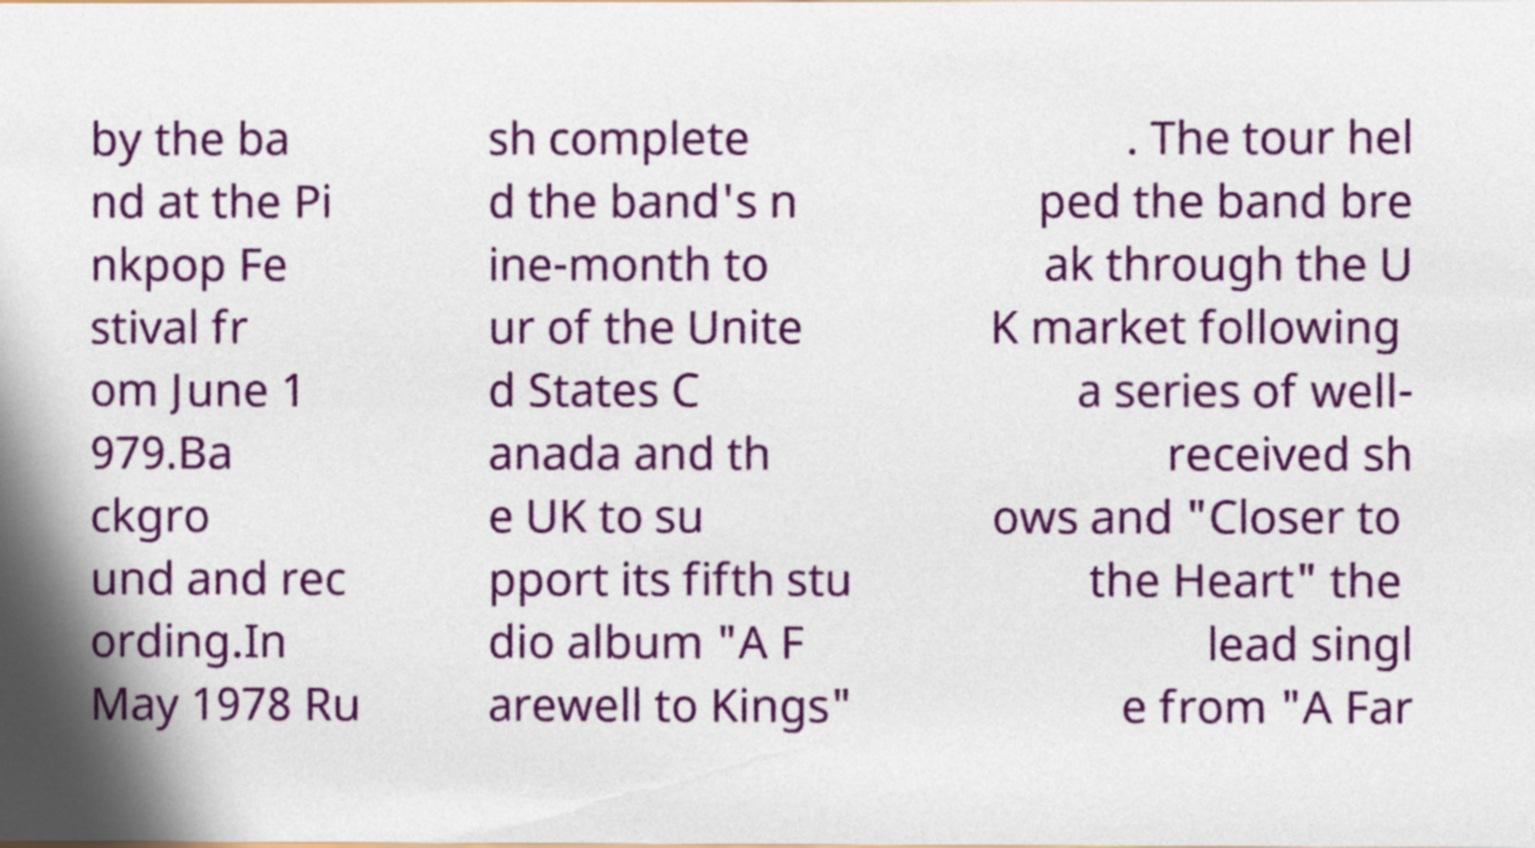Can you read and provide the text displayed in the image?This photo seems to have some interesting text. Can you extract and type it out for me? by the ba nd at the Pi nkpop Fe stival fr om June 1 979.Ba ckgro und and rec ording.In May 1978 Ru sh complete d the band's n ine-month to ur of the Unite d States C anada and th e UK to su pport its fifth stu dio album "A F arewell to Kings" . The tour hel ped the band bre ak through the U K market following a series of well- received sh ows and "Closer to the Heart" the lead singl e from "A Far 